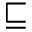<formula> <loc_0><loc_0><loc_500><loc_500>\sqsubseteq</formula> 